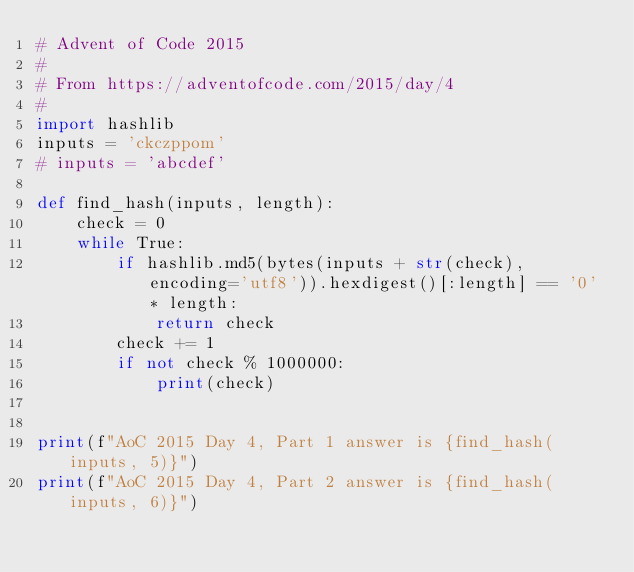Convert code to text. <code><loc_0><loc_0><loc_500><loc_500><_Python_># Advent of Code 2015
#
# From https://adventofcode.com/2015/day/4
#
import hashlib
inputs = 'ckczppom'
# inputs = 'abcdef'

def find_hash(inputs, length):
    check = 0
    while True:
        if hashlib.md5(bytes(inputs + str(check), encoding='utf8')).hexdigest()[:length] == '0' * length:
            return check
        check += 1
        if not check % 1000000:
            print(check)


print(f"AoC 2015 Day 4, Part 1 answer is {find_hash(inputs, 5)}")
print(f"AoC 2015 Day 4, Part 2 answer is {find_hash(inputs, 6)}")</code> 